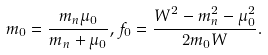<formula> <loc_0><loc_0><loc_500><loc_500>m _ { 0 } = \frac { m _ { n } \mu _ { 0 } } { m _ { n } + \mu _ { 0 } } , f _ { 0 } = \frac { W ^ { 2 } - m _ { n } ^ { 2 } - \mu _ { 0 } ^ { 2 } } { 2 m _ { 0 } W } .</formula> 